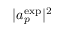Convert formula to latex. <formula><loc_0><loc_0><loc_500><loc_500>| a _ { p } ^ { e x p } | ^ { 2 }</formula> 